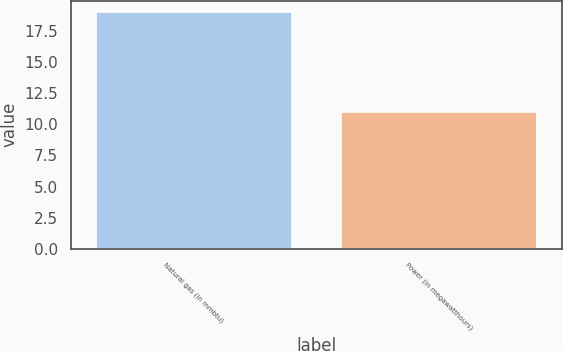Convert chart to OTSL. <chart><loc_0><loc_0><loc_500><loc_500><bar_chart><fcel>Natural gas (in mmbtu)<fcel>Power (in megawatthours)<nl><fcel>19<fcel>11<nl></chart> 